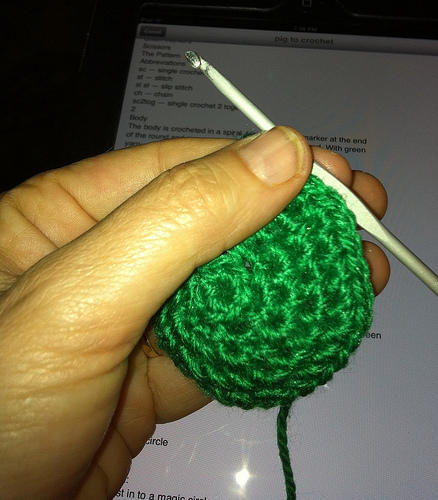<image>
Is the hook in the wool? No. The hook is not contained within the wool. These objects have a different spatial relationship. 